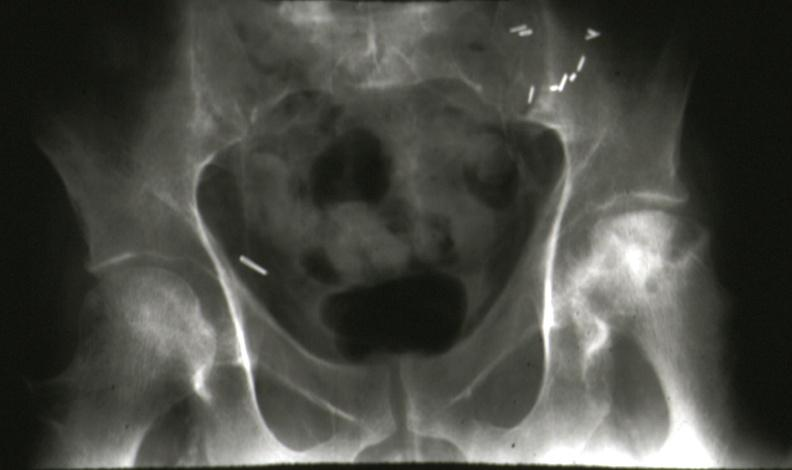does this image show x-ray pelvis showing very nicely bilateral femoral head necrosis renal transplant case?
Answer the question using a single word or phrase. Yes 